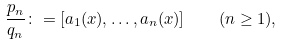Convert formula to latex. <formula><loc_0><loc_0><loc_500><loc_500>\frac { p _ { n } } { q _ { n } } \colon = [ a _ { 1 } ( x ) , \dots , a _ { n } ( x ) ] \quad ( n \geq 1 ) ,</formula> 